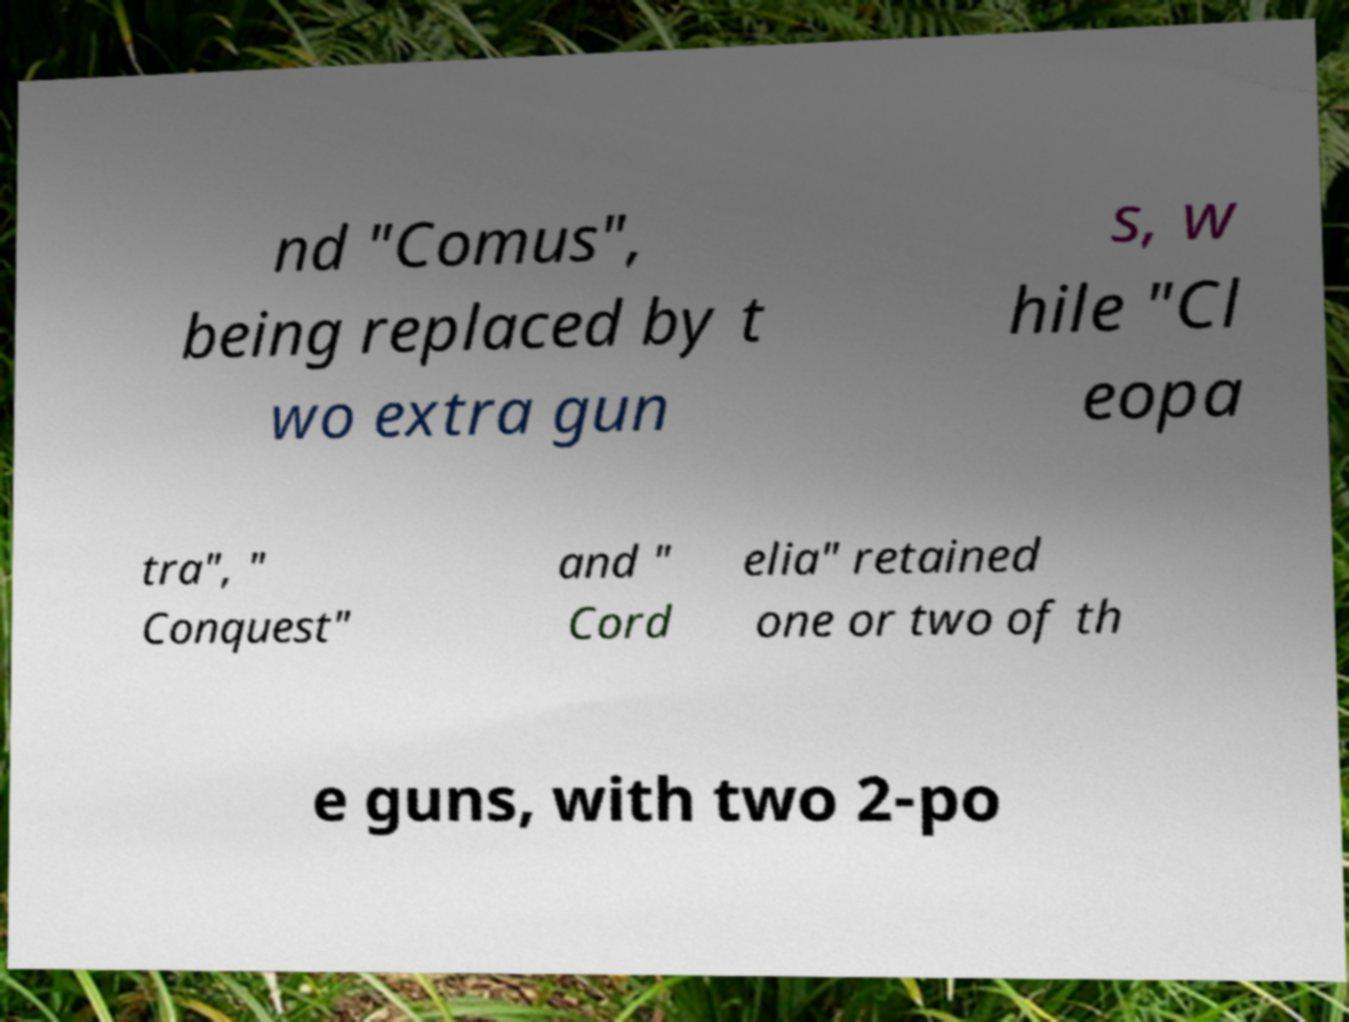I need the written content from this picture converted into text. Can you do that? nd "Comus", being replaced by t wo extra gun s, w hile "Cl eopa tra", " Conquest" and " Cord elia" retained one or two of th e guns, with two 2-po 